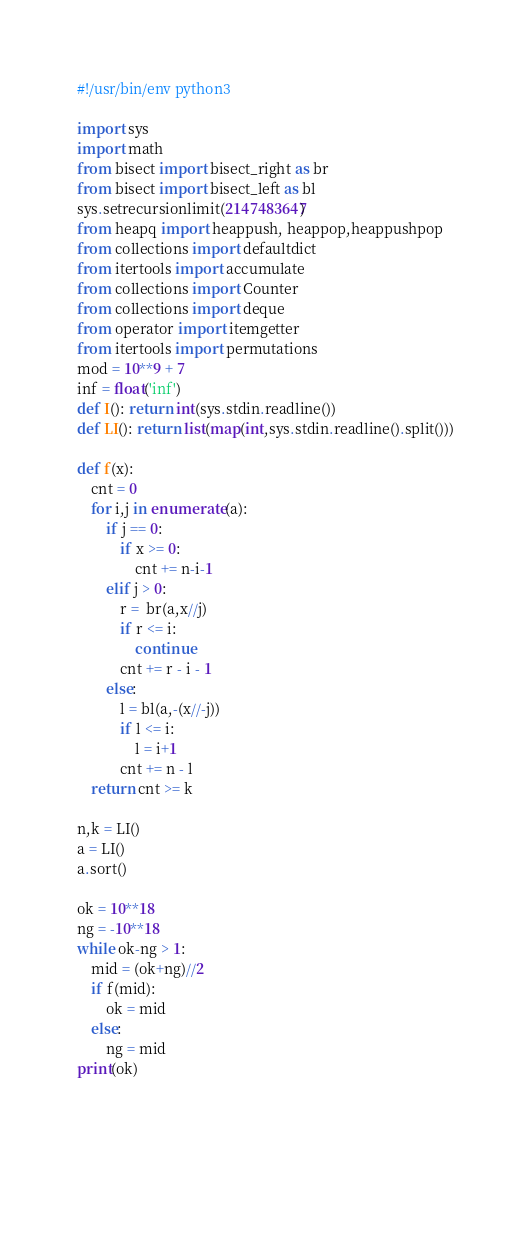<code> <loc_0><loc_0><loc_500><loc_500><_Python_>#!/usr/bin/env python3

import sys
import math
from bisect import bisect_right as br
from bisect import bisect_left as bl
sys.setrecursionlimit(2147483647)
from heapq import heappush, heappop,heappushpop
from collections import defaultdict
from itertools import accumulate
from collections import Counter
from collections import deque
from operator import itemgetter
from itertools import permutations
mod = 10**9 + 7
inf = float('inf')
def I(): return int(sys.stdin.readline())
def LI(): return list(map(int,sys.stdin.readline().split()))

def f(x):
    cnt = 0
    for i,j in enumerate(a):
        if j == 0:
            if x >= 0:
                cnt += n-i-1
        elif j > 0:
            r =  br(a,x//j)
            if r <= i:
                continue
            cnt += r - i - 1
        else:
            l = bl(a,-(x//-j))
            if l <= i:
                l = i+1
            cnt += n - l
    return cnt >= k

n,k = LI()
a = LI()
a.sort()

ok = 10**18
ng = -10**18
while ok-ng > 1:
    mid = (ok+ng)//2
    if f(mid):
        ok = mid
    else:
        ng = mid
print(ok)



    </code> 